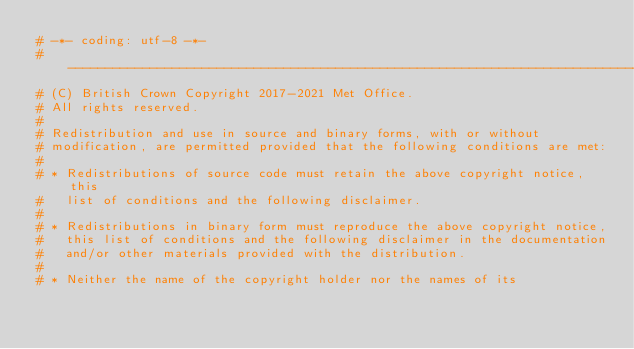Convert code to text. <code><loc_0><loc_0><loc_500><loc_500><_Python_># -*- coding: utf-8 -*-
# -----------------------------------------------------------------------------
# (C) British Crown Copyright 2017-2021 Met Office.
# All rights reserved.
#
# Redistribution and use in source and binary forms, with or without
# modification, are permitted provided that the following conditions are met:
#
# * Redistributions of source code must retain the above copyright notice, this
#   list of conditions and the following disclaimer.
#
# * Redistributions in binary form must reproduce the above copyright notice,
#   this list of conditions and the following disclaimer in the documentation
#   and/or other materials provided with the distribution.
#
# * Neither the name of the copyright holder nor the names of its</code> 